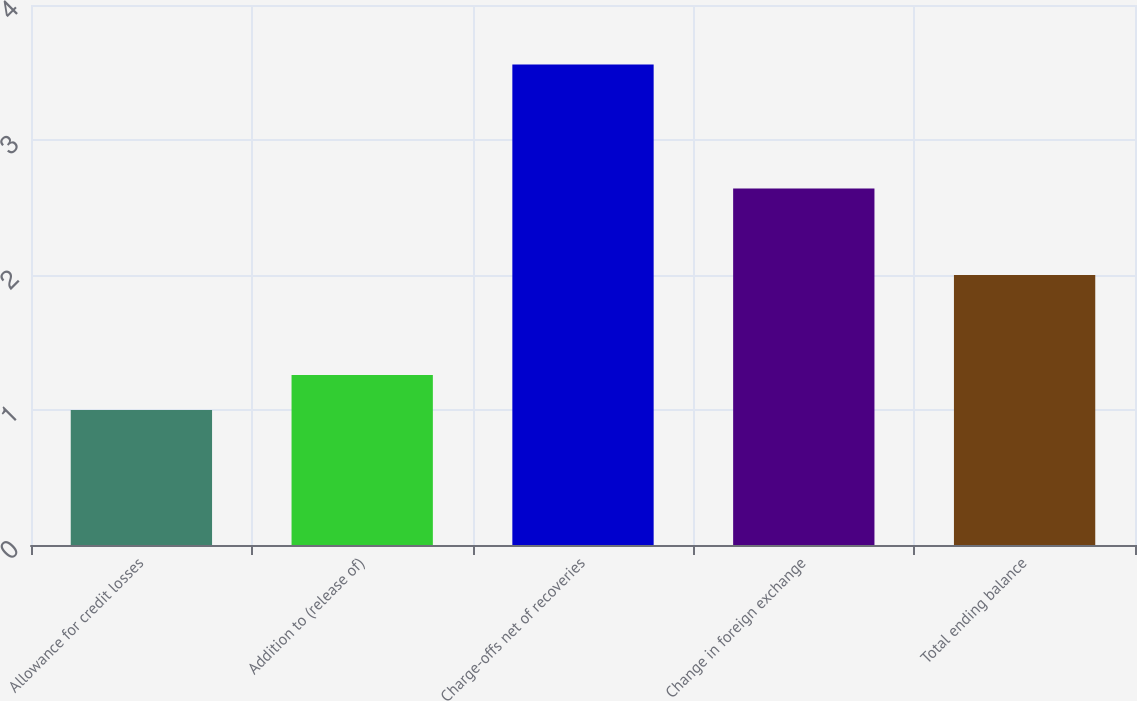Convert chart. <chart><loc_0><loc_0><loc_500><loc_500><bar_chart><fcel>Allowance for credit losses<fcel>Addition to (release of)<fcel>Charge-offs net of recoveries<fcel>Change in foreign exchange<fcel>Total ending balance<nl><fcel>1<fcel>1.26<fcel>3.56<fcel>2.64<fcel>2<nl></chart> 